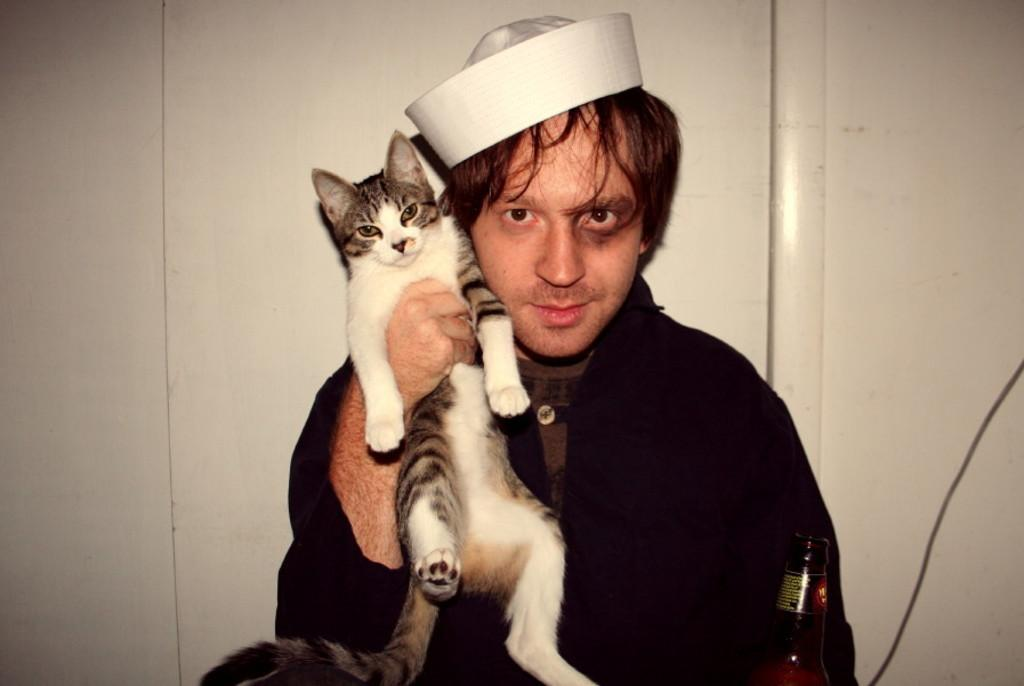What is the color of the wall in the image? The wall in the image is white. What is the man in the image holding? The man in the image is holding a cat. Where is the baby in the image? There is no baby present in the image; it features a man holding a cat. What type of veil can be seen in the image? There is no veil present in the image. 